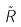Convert formula to latex. <formula><loc_0><loc_0><loc_500><loc_500>\tilde { R }</formula> 